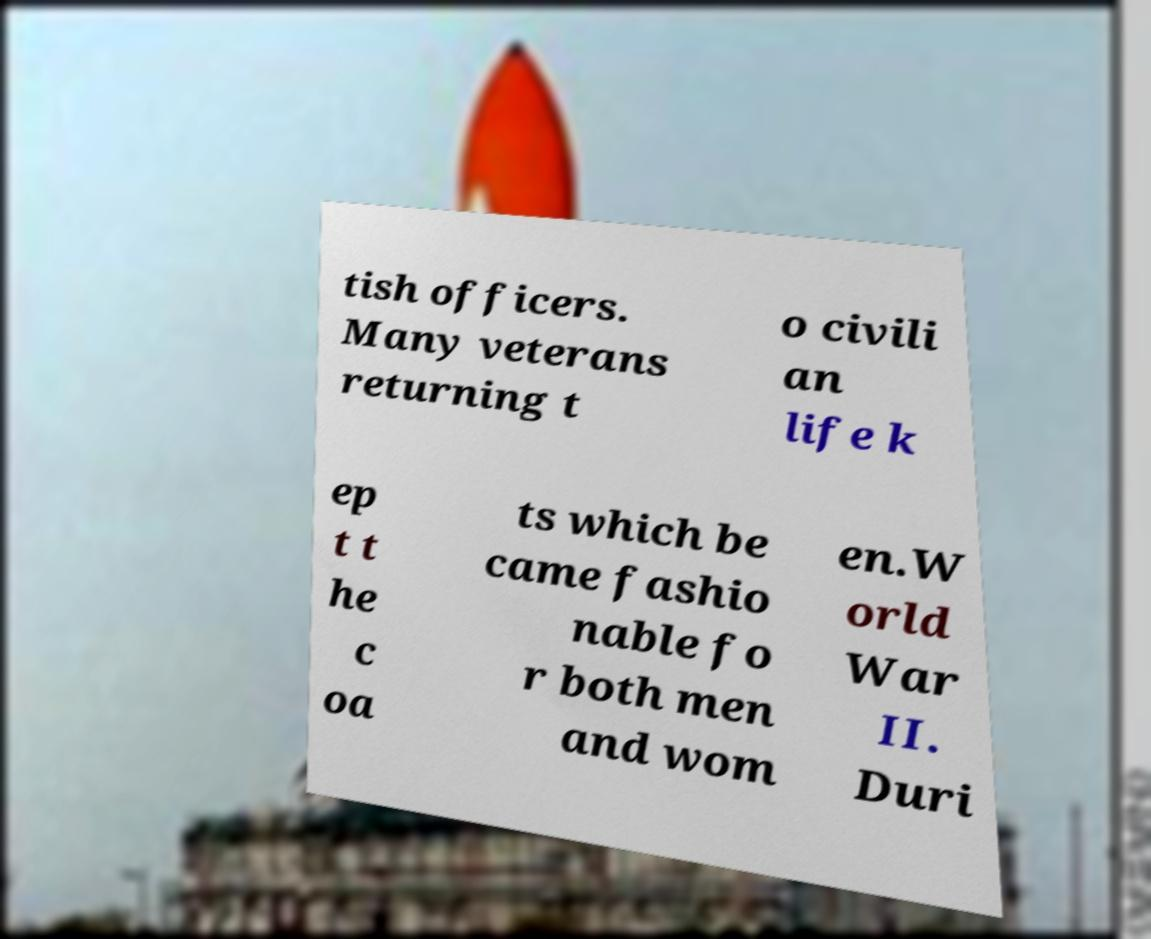There's text embedded in this image that I need extracted. Can you transcribe it verbatim? tish officers. Many veterans returning t o civili an life k ep t t he c oa ts which be came fashio nable fo r both men and wom en.W orld War II. Duri 